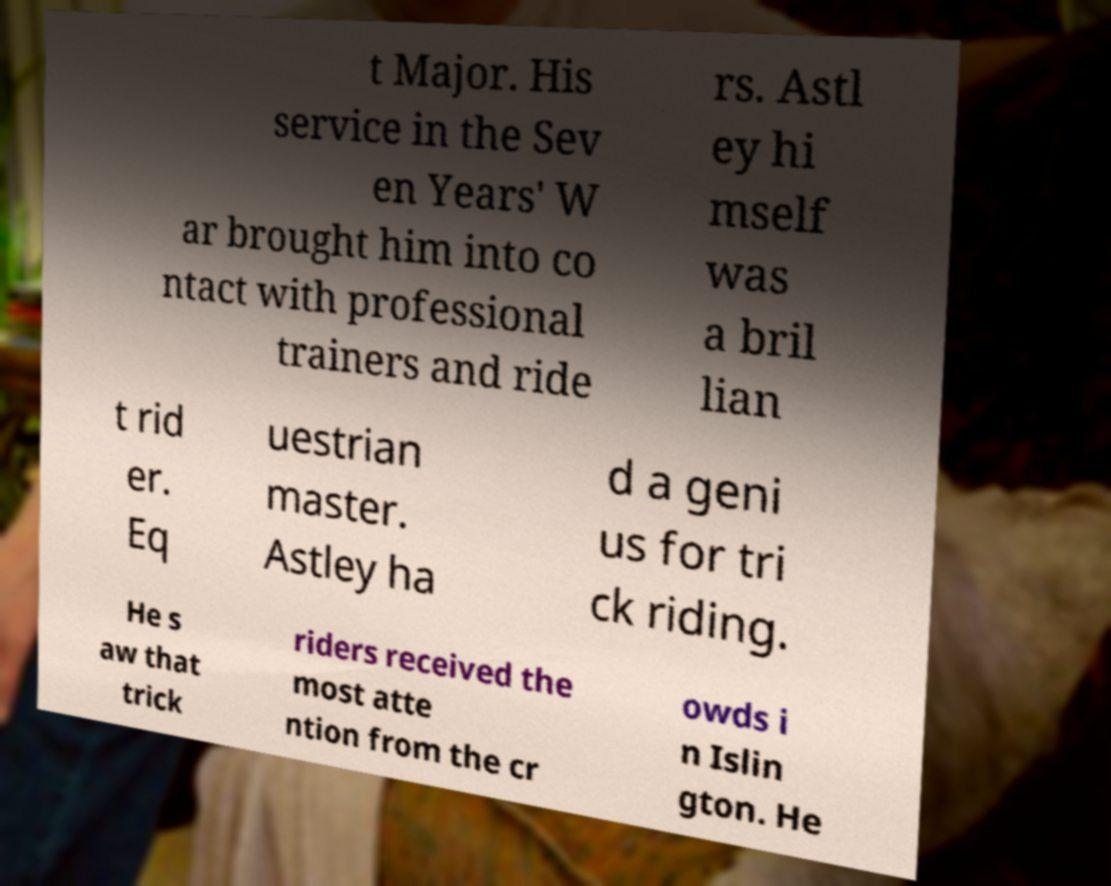There's text embedded in this image that I need extracted. Can you transcribe it verbatim? t Major. His service in the Sev en Years' W ar brought him into co ntact with professional trainers and ride rs. Astl ey hi mself was a bril lian t rid er. Eq uestrian master. Astley ha d a geni us for tri ck riding. He s aw that trick riders received the most atte ntion from the cr owds i n Islin gton. He 